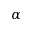Convert formula to latex. <formula><loc_0><loc_0><loc_500><loc_500>\alpha</formula> 